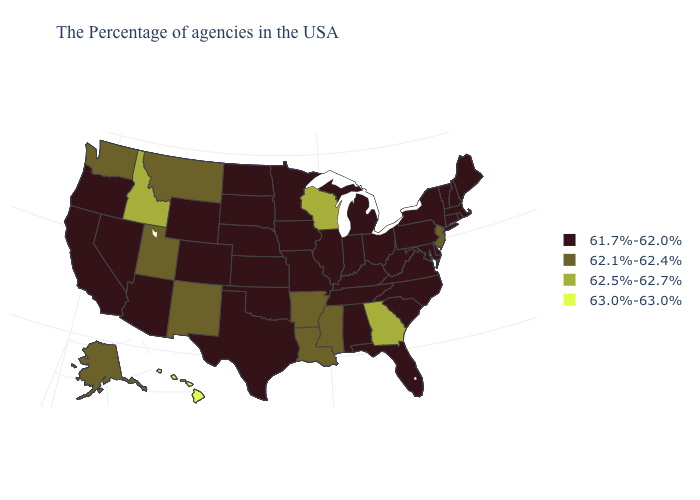What is the value of Rhode Island?
Keep it brief. 61.7%-62.0%. Which states have the lowest value in the MidWest?
Concise answer only. Ohio, Michigan, Indiana, Illinois, Missouri, Minnesota, Iowa, Kansas, Nebraska, South Dakota, North Dakota. Which states have the lowest value in the USA?
Short answer required. Maine, Massachusetts, Rhode Island, New Hampshire, Vermont, Connecticut, New York, Delaware, Maryland, Pennsylvania, Virginia, North Carolina, South Carolina, West Virginia, Ohio, Florida, Michigan, Kentucky, Indiana, Alabama, Tennessee, Illinois, Missouri, Minnesota, Iowa, Kansas, Nebraska, Oklahoma, Texas, South Dakota, North Dakota, Wyoming, Colorado, Arizona, Nevada, California, Oregon. Does Kentucky have the highest value in the USA?
Short answer required. No. Name the states that have a value in the range 62.1%-62.4%?
Concise answer only. New Jersey, Mississippi, Louisiana, Arkansas, New Mexico, Utah, Montana, Washington, Alaska. Does the map have missing data?
Concise answer only. No. Name the states that have a value in the range 61.7%-62.0%?
Be succinct. Maine, Massachusetts, Rhode Island, New Hampshire, Vermont, Connecticut, New York, Delaware, Maryland, Pennsylvania, Virginia, North Carolina, South Carolina, West Virginia, Ohio, Florida, Michigan, Kentucky, Indiana, Alabama, Tennessee, Illinois, Missouri, Minnesota, Iowa, Kansas, Nebraska, Oklahoma, Texas, South Dakota, North Dakota, Wyoming, Colorado, Arizona, Nevada, California, Oregon. Name the states that have a value in the range 62.1%-62.4%?
Quick response, please. New Jersey, Mississippi, Louisiana, Arkansas, New Mexico, Utah, Montana, Washington, Alaska. Does the first symbol in the legend represent the smallest category?
Be succinct. Yes. How many symbols are there in the legend?
Answer briefly. 4. What is the value of Kansas?
Concise answer only. 61.7%-62.0%. Does Tennessee have a lower value than Arizona?
Give a very brief answer. No. Does Nebraska have a higher value than Iowa?
Answer briefly. No. What is the lowest value in the USA?
Write a very short answer. 61.7%-62.0%. Does North Dakota have a lower value than West Virginia?
Be succinct. No. 